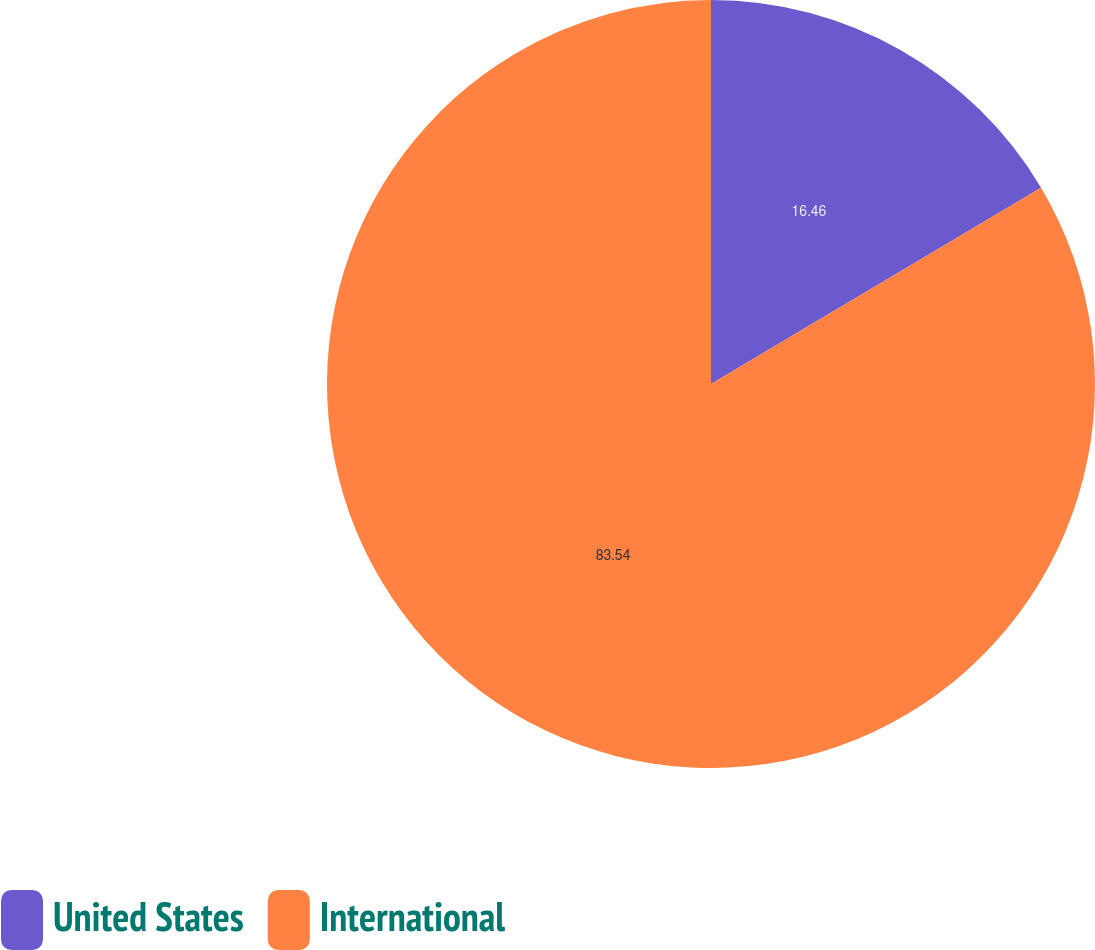<chart> <loc_0><loc_0><loc_500><loc_500><pie_chart><fcel>United States<fcel>International<nl><fcel>16.46%<fcel>83.54%<nl></chart> 